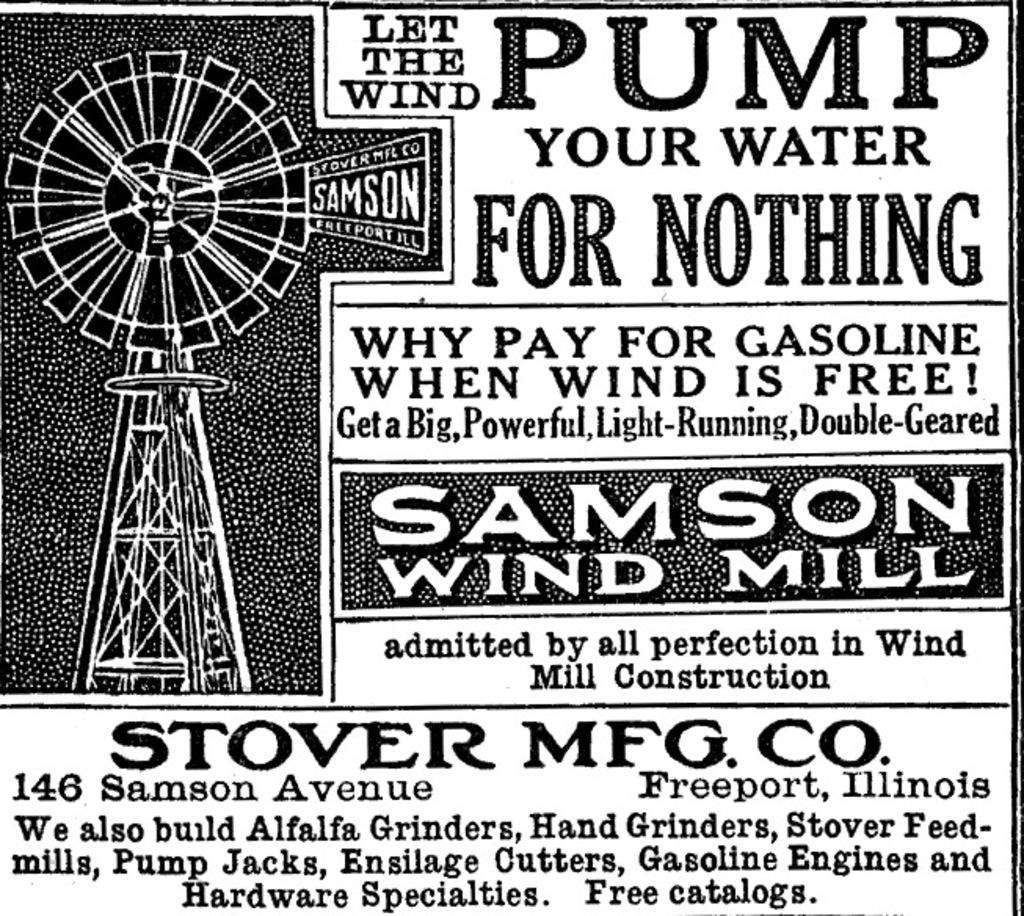<image>
Relay a brief, clear account of the picture shown. a poster with the word pump at the top 